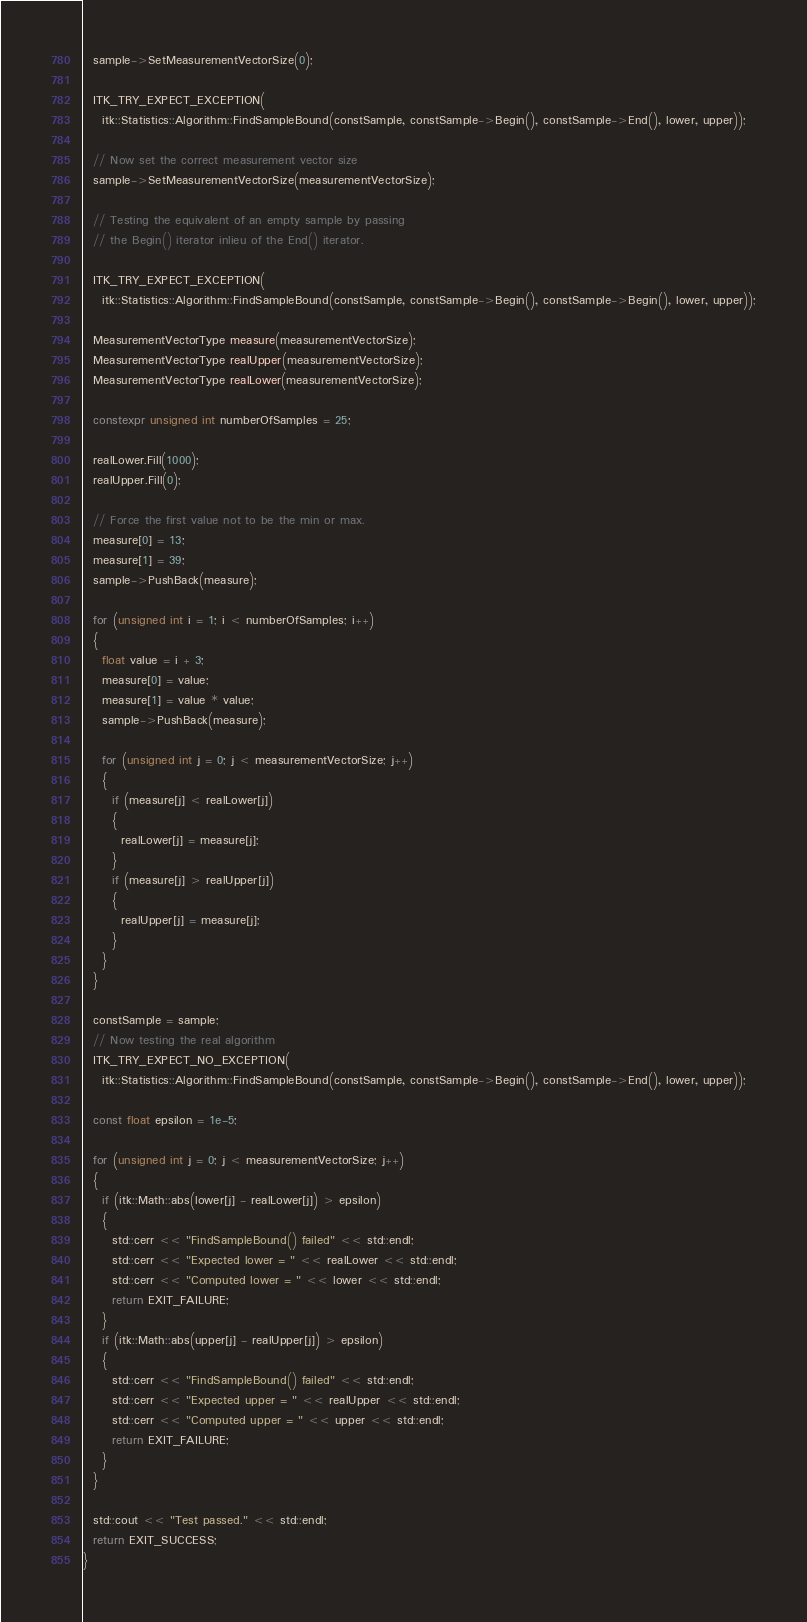<code> <loc_0><loc_0><loc_500><loc_500><_C++_>  sample->SetMeasurementVectorSize(0);

  ITK_TRY_EXPECT_EXCEPTION(
    itk::Statistics::Algorithm::FindSampleBound(constSample, constSample->Begin(), constSample->End(), lower, upper));

  // Now set the correct measurement vector size
  sample->SetMeasurementVectorSize(measurementVectorSize);

  // Testing the equivalent of an empty sample by passing
  // the Begin() iterator inlieu of the End() iterator.

  ITK_TRY_EXPECT_EXCEPTION(
    itk::Statistics::Algorithm::FindSampleBound(constSample, constSample->Begin(), constSample->Begin(), lower, upper));

  MeasurementVectorType measure(measurementVectorSize);
  MeasurementVectorType realUpper(measurementVectorSize);
  MeasurementVectorType realLower(measurementVectorSize);

  constexpr unsigned int numberOfSamples = 25;

  realLower.Fill(1000);
  realUpper.Fill(0);

  // Force the first value not to be the min or max.
  measure[0] = 13;
  measure[1] = 39;
  sample->PushBack(measure);

  for (unsigned int i = 1; i < numberOfSamples; i++)
  {
    float value = i + 3;
    measure[0] = value;
    measure[1] = value * value;
    sample->PushBack(measure);

    for (unsigned int j = 0; j < measurementVectorSize; j++)
    {
      if (measure[j] < realLower[j])
      {
        realLower[j] = measure[j];
      }
      if (measure[j] > realUpper[j])
      {
        realUpper[j] = measure[j];
      }
    }
  }

  constSample = sample;
  // Now testing the real algorithm
  ITK_TRY_EXPECT_NO_EXCEPTION(
    itk::Statistics::Algorithm::FindSampleBound(constSample, constSample->Begin(), constSample->End(), lower, upper));

  const float epsilon = 1e-5;

  for (unsigned int j = 0; j < measurementVectorSize; j++)
  {
    if (itk::Math::abs(lower[j] - realLower[j]) > epsilon)
    {
      std::cerr << "FindSampleBound() failed" << std::endl;
      std::cerr << "Expected lower = " << realLower << std::endl;
      std::cerr << "Computed lower = " << lower << std::endl;
      return EXIT_FAILURE;
    }
    if (itk::Math::abs(upper[j] - realUpper[j]) > epsilon)
    {
      std::cerr << "FindSampleBound() failed" << std::endl;
      std::cerr << "Expected upper = " << realUpper << std::endl;
      std::cerr << "Computed upper = " << upper << std::endl;
      return EXIT_FAILURE;
    }
  }

  std::cout << "Test passed." << std::endl;
  return EXIT_SUCCESS;
}
</code> 